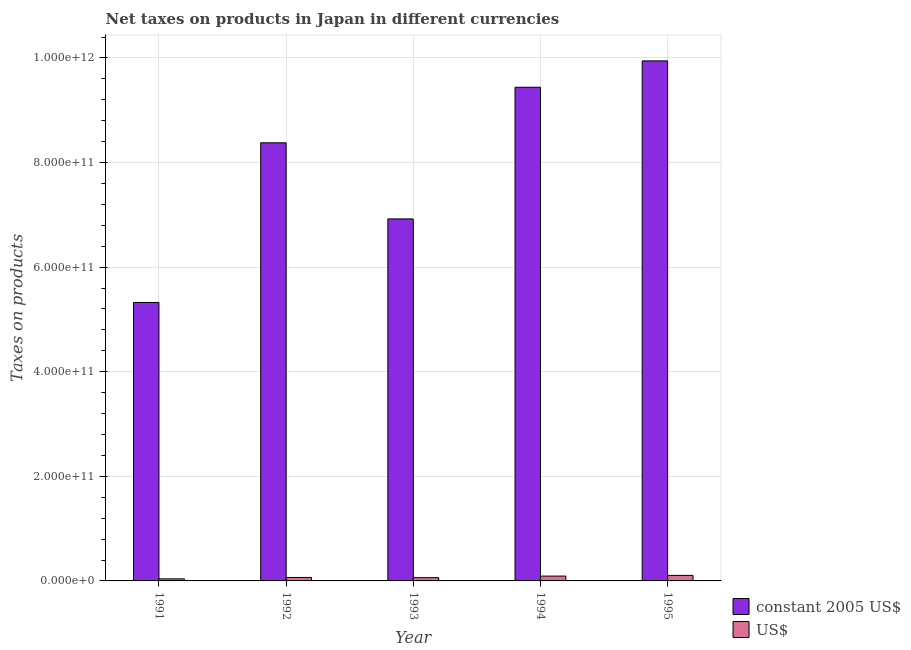How many different coloured bars are there?
Provide a succinct answer. 2. How many groups of bars are there?
Ensure brevity in your answer.  5. Are the number of bars per tick equal to the number of legend labels?
Give a very brief answer. Yes. What is the net taxes in us$ in 1993?
Give a very brief answer. 6.23e+09. Across all years, what is the maximum net taxes in constant 2005 us$?
Your answer should be compact. 9.94e+11. Across all years, what is the minimum net taxes in us$?
Offer a terse response. 3.95e+09. What is the total net taxes in us$ in the graph?
Ensure brevity in your answer.  3.66e+1. What is the difference between the net taxes in us$ in 1992 and that in 1994?
Your answer should be compact. -2.62e+09. What is the difference between the net taxes in us$ in 1994 and the net taxes in constant 2005 us$ in 1991?
Ensure brevity in your answer.  5.28e+09. What is the average net taxes in constant 2005 us$ per year?
Ensure brevity in your answer.  8.00e+11. In the year 1991, what is the difference between the net taxes in us$ and net taxes in constant 2005 us$?
Keep it short and to the point. 0. What is the ratio of the net taxes in constant 2005 us$ in 1993 to that in 1994?
Ensure brevity in your answer.  0.73. What is the difference between the highest and the second highest net taxes in constant 2005 us$?
Your answer should be very brief. 5.04e+1. What is the difference between the highest and the lowest net taxes in us$?
Your answer should be very brief. 6.62e+09. In how many years, is the net taxes in us$ greater than the average net taxes in us$ taken over all years?
Offer a terse response. 2. What does the 2nd bar from the left in 1995 represents?
Your answer should be compact. US$. What does the 2nd bar from the right in 1992 represents?
Your answer should be very brief. Constant 2005 us$. What is the difference between two consecutive major ticks on the Y-axis?
Provide a short and direct response. 2.00e+11. Are the values on the major ticks of Y-axis written in scientific E-notation?
Provide a succinct answer. Yes. Does the graph contain any zero values?
Your answer should be compact. No. Where does the legend appear in the graph?
Your answer should be very brief. Bottom right. How many legend labels are there?
Your answer should be very brief. 2. How are the legend labels stacked?
Your answer should be very brief. Vertical. What is the title of the graph?
Make the answer very short. Net taxes on products in Japan in different currencies. Does "Male" appear as one of the legend labels in the graph?
Your answer should be compact. No. What is the label or title of the X-axis?
Your response must be concise. Year. What is the label or title of the Y-axis?
Your response must be concise. Taxes on products. What is the Taxes on products of constant 2005 US$ in 1991?
Offer a terse response. 5.32e+11. What is the Taxes on products in US$ in 1991?
Your response must be concise. 3.95e+09. What is the Taxes on products of constant 2005 US$ in 1992?
Provide a short and direct response. 8.38e+11. What is the Taxes on products of US$ in 1992?
Make the answer very short. 6.61e+09. What is the Taxes on products in constant 2005 US$ in 1993?
Provide a succinct answer. 6.92e+11. What is the Taxes on products in US$ in 1993?
Offer a very short reply. 6.23e+09. What is the Taxes on products of constant 2005 US$ in 1994?
Provide a succinct answer. 9.44e+11. What is the Taxes on products of US$ in 1994?
Your answer should be compact. 9.24e+09. What is the Taxes on products of constant 2005 US$ in 1995?
Keep it short and to the point. 9.94e+11. What is the Taxes on products in US$ in 1995?
Give a very brief answer. 1.06e+1. Across all years, what is the maximum Taxes on products of constant 2005 US$?
Make the answer very short. 9.94e+11. Across all years, what is the maximum Taxes on products of US$?
Give a very brief answer. 1.06e+1. Across all years, what is the minimum Taxes on products of constant 2005 US$?
Your answer should be compact. 5.32e+11. Across all years, what is the minimum Taxes on products of US$?
Give a very brief answer. 3.95e+09. What is the total Taxes on products in constant 2005 US$ in the graph?
Make the answer very short. 4.00e+12. What is the total Taxes on products of US$ in the graph?
Ensure brevity in your answer.  3.66e+1. What is the difference between the Taxes on products in constant 2005 US$ in 1991 and that in 1992?
Give a very brief answer. -3.05e+11. What is the difference between the Taxes on products in US$ in 1991 and that in 1992?
Your answer should be compact. -2.66e+09. What is the difference between the Taxes on products of constant 2005 US$ in 1991 and that in 1993?
Offer a terse response. -1.60e+11. What is the difference between the Taxes on products in US$ in 1991 and that in 1993?
Give a very brief answer. -2.27e+09. What is the difference between the Taxes on products in constant 2005 US$ in 1991 and that in 1994?
Give a very brief answer. -4.12e+11. What is the difference between the Taxes on products of US$ in 1991 and that in 1994?
Your answer should be compact. -5.28e+09. What is the difference between the Taxes on products of constant 2005 US$ in 1991 and that in 1995?
Your answer should be compact. -4.62e+11. What is the difference between the Taxes on products of US$ in 1991 and that in 1995?
Make the answer very short. -6.62e+09. What is the difference between the Taxes on products in constant 2005 US$ in 1992 and that in 1993?
Ensure brevity in your answer.  1.46e+11. What is the difference between the Taxes on products of US$ in 1992 and that in 1993?
Your answer should be compact. 3.90e+08. What is the difference between the Taxes on products of constant 2005 US$ in 1992 and that in 1994?
Give a very brief answer. -1.06e+11. What is the difference between the Taxes on products of US$ in 1992 and that in 1994?
Provide a succinct answer. -2.62e+09. What is the difference between the Taxes on products of constant 2005 US$ in 1992 and that in 1995?
Your answer should be very brief. -1.57e+11. What is the difference between the Taxes on products in US$ in 1992 and that in 1995?
Keep it short and to the point. -3.96e+09. What is the difference between the Taxes on products in constant 2005 US$ in 1993 and that in 1994?
Give a very brief answer. -2.52e+11. What is the difference between the Taxes on products in US$ in 1993 and that in 1994?
Offer a terse response. -3.01e+09. What is the difference between the Taxes on products in constant 2005 US$ in 1993 and that in 1995?
Give a very brief answer. -3.02e+11. What is the difference between the Taxes on products of US$ in 1993 and that in 1995?
Your answer should be compact. -4.35e+09. What is the difference between the Taxes on products in constant 2005 US$ in 1994 and that in 1995?
Provide a short and direct response. -5.04e+1. What is the difference between the Taxes on products of US$ in 1994 and that in 1995?
Provide a short and direct response. -1.34e+09. What is the difference between the Taxes on products of constant 2005 US$ in 1991 and the Taxes on products of US$ in 1992?
Provide a succinct answer. 5.26e+11. What is the difference between the Taxes on products in constant 2005 US$ in 1991 and the Taxes on products in US$ in 1993?
Ensure brevity in your answer.  5.26e+11. What is the difference between the Taxes on products of constant 2005 US$ in 1991 and the Taxes on products of US$ in 1994?
Provide a short and direct response. 5.23e+11. What is the difference between the Taxes on products of constant 2005 US$ in 1991 and the Taxes on products of US$ in 1995?
Your answer should be very brief. 5.22e+11. What is the difference between the Taxes on products of constant 2005 US$ in 1992 and the Taxes on products of US$ in 1993?
Ensure brevity in your answer.  8.32e+11. What is the difference between the Taxes on products in constant 2005 US$ in 1992 and the Taxes on products in US$ in 1994?
Make the answer very short. 8.29e+11. What is the difference between the Taxes on products in constant 2005 US$ in 1992 and the Taxes on products in US$ in 1995?
Keep it short and to the point. 8.27e+11. What is the difference between the Taxes on products in constant 2005 US$ in 1993 and the Taxes on products in US$ in 1994?
Give a very brief answer. 6.83e+11. What is the difference between the Taxes on products of constant 2005 US$ in 1993 and the Taxes on products of US$ in 1995?
Make the answer very short. 6.82e+11. What is the difference between the Taxes on products of constant 2005 US$ in 1994 and the Taxes on products of US$ in 1995?
Keep it short and to the point. 9.33e+11. What is the average Taxes on products in constant 2005 US$ per year?
Your answer should be very brief. 8.00e+11. What is the average Taxes on products of US$ per year?
Offer a very short reply. 7.32e+09. In the year 1991, what is the difference between the Taxes on products of constant 2005 US$ and Taxes on products of US$?
Provide a short and direct response. 5.28e+11. In the year 1992, what is the difference between the Taxes on products in constant 2005 US$ and Taxes on products in US$?
Your response must be concise. 8.31e+11. In the year 1993, what is the difference between the Taxes on products of constant 2005 US$ and Taxes on products of US$?
Your response must be concise. 6.86e+11. In the year 1994, what is the difference between the Taxes on products in constant 2005 US$ and Taxes on products in US$?
Keep it short and to the point. 9.35e+11. In the year 1995, what is the difference between the Taxes on products of constant 2005 US$ and Taxes on products of US$?
Offer a very short reply. 9.84e+11. What is the ratio of the Taxes on products of constant 2005 US$ in 1991 to that in 1992?
Your response must be concise. 0.64. What is the ratio of the Taxes on products of US$ in 1991 to that in 1992?
Offer a very short reply. 0.6. What is the ratio of the Taxes on products in constant 2005 US$ in 1991 to that in 1993?
Provide a short and direct response. 0.77. What is the ratio of the Taxes on products in US$ in 1991 to that in 1993?
Your response must be concise. 0.63. What is the ratio of the Taxes on products in constant 2005 US$ in 1991 to that in 1994?
Your answer should be very brief. 0.56. What is the ratio of the Taxes on products of US$ in 1991 to that in 1994?
Provide a succinct answer. 0.43. What is the ratio of the Taxes on products of constant 2005 US$ in 1991 to that in 1995?
Your answer should be compact. 0.54. What is the ratio of the Taxes on products of US$ in 1991 to that in 1995?
Keep it short and to the point. 0.37. What is the ratio of the Taxes on products in constant 2005 US$ in 1992 to that in 1993?
Your answer should be compact. 1.21. What is the ratio of the Taxes on products of US$ in 1992 to that in 1993?
Offer a very short reply. 1.06. What is the ratio of the Taxes on products of constant 2005 US$ in 1992 to that in 1994?
Ensure brevity in your answer.  0.89. What is the ratio of the Taxes on products of US$ in 1992 to that in 1994?
Your answer should be compact. 0.72. What is the ratio of the Taxes on products of constant 2005 US$ in 1992 to that in 1995?
Provide a short and direct response. 0.84. What is the ratio of the Taxes on products in US$ in 1992 to that in 1995?
Ensure brevity in your answer.  0.63. What is the ratio of the Taxes on products of constant 2005 US$ in 1993 to that in 1994?
Keep it short and to the point. 0.73. What is the ratio of the Taxes on products of US$ in 1993 to that in 1994?
Keep it short and to the point. 0.67. What is the ratio of the Taxes on products of constant 2005 US$ in 1993 to that in 1995?
Your response must be concise. 0.7. What is the ratio of the Taxes on products of US$ in 1993 to that in 1995?
Ensure brevity in your answer.  0.59. What is the ratio of the Taxes on products in constant 2005 US$ in 1994 to that in 1995?
Offer a very short reply. 0.95. What is the ratio of the Taxes on products in US$ in 1994 to that in 1995?
Keep it short and to the point. 0.87. What is the difference between the highest and the second highest Taxes on products in constant 2005 US$?
Offer a terse response. 5.04e+1. What is the difference between the highest and the second highest Taxes on products in US$?
Make the answer very short. 1.34e+09. What is the difference between the highest and the lowest Taxes on products in constant 2005 US$?
Your response must be concise. 4.62e+11. What is the difference between the highest and the lowest Taxes on products in US$?
Make the answer very short. 6.62e+09. 